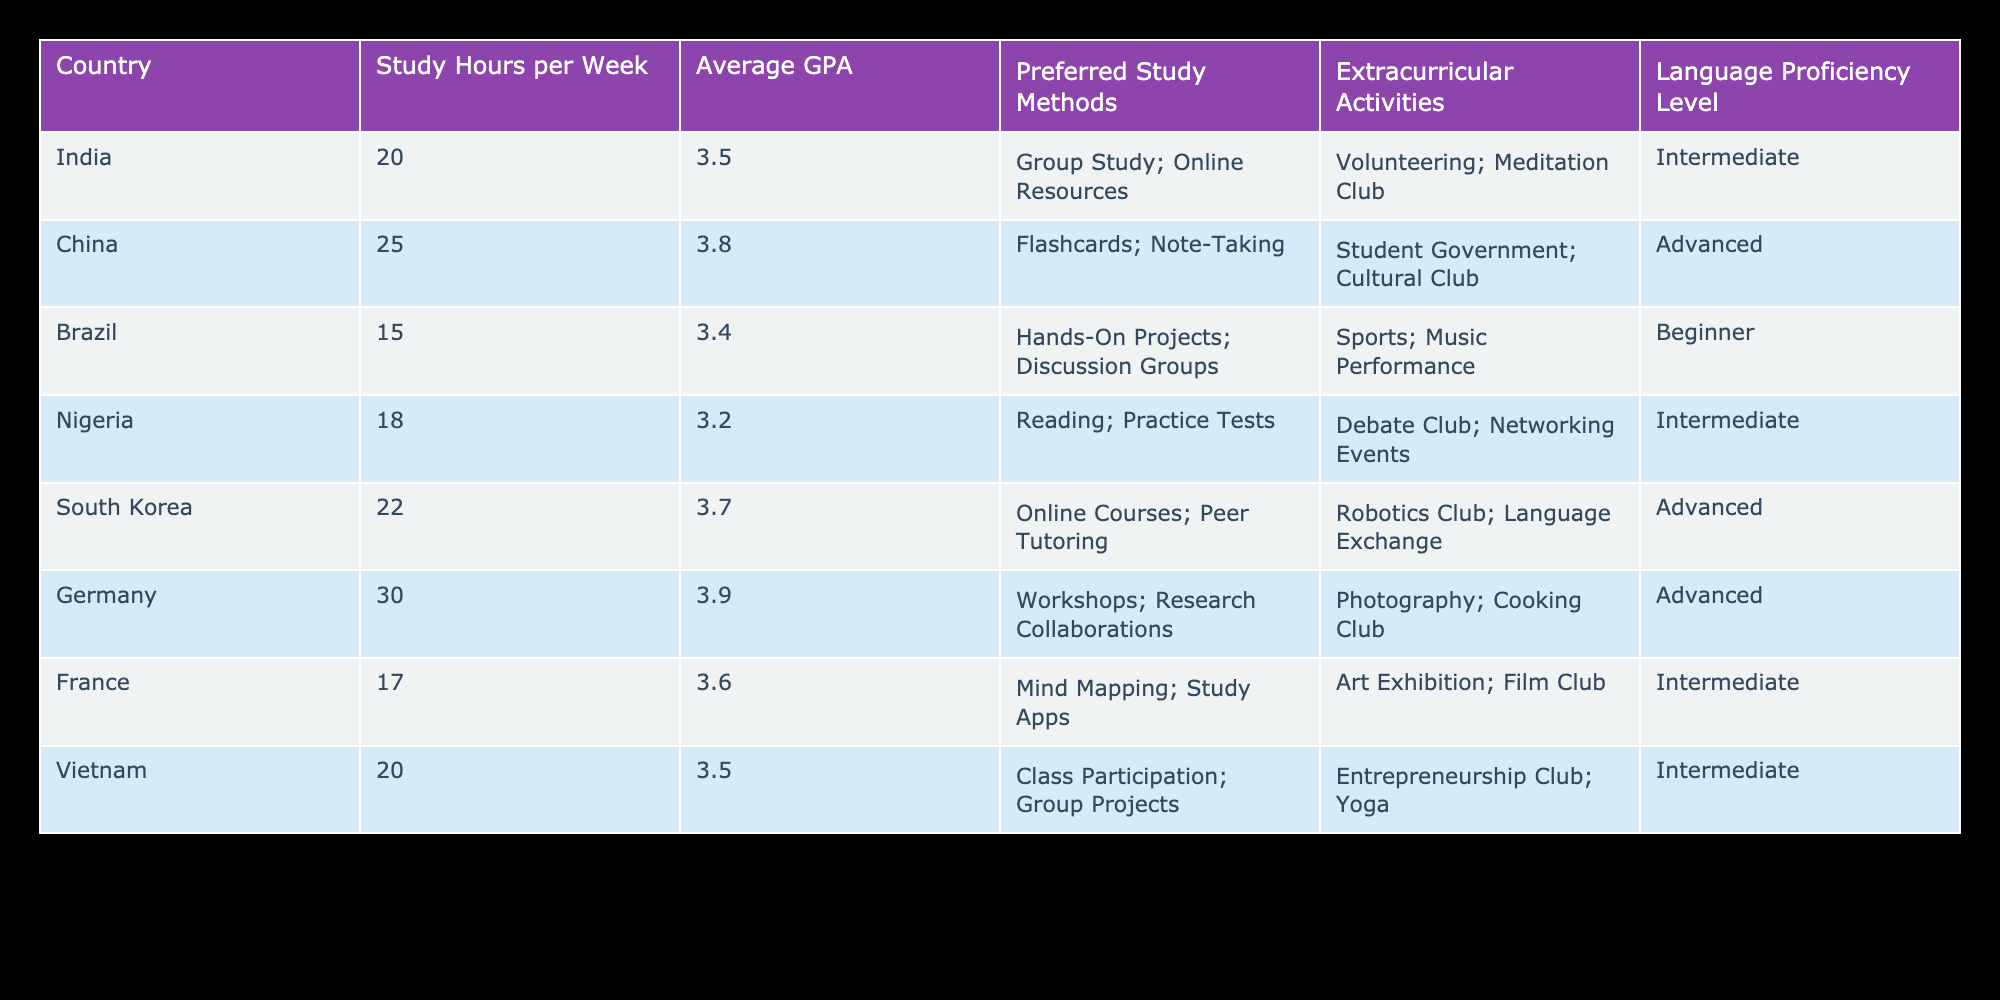What is the average GPA of the students from India? From the table, the GPA for students from India is 3.5. As there is only one entry for India, the average GPA is the same as the individual GPA value.
Answer: 3.5 Which country has the highest average GPA? By comparing the GPA values in the table, Germany has the GPA of 3.9, which is the highest among all the countries listed.
Answer: Germany What study method is preferred by students from Brazil? According to the table, students from Brazil prefer "Hands-On Projects" and "Discussion Groups" as their study methods.
Answer: Hands-On Projects; Discussion Groups Is it true that students from Nigeria have better language proficiency levels than those from Brazil? The table indicates that Nigeria has an "Intermediate" language proficiency level while Brazil has a "Beginner" level. Therefore, it is true that students from Nigeria have better language proficiency levels than those from Brazil.
Answer: Yes What is the difference in study hours per week between students from China and those from France? The study hours for China are 25, and for France, it’s 17. To find the difference, subtract the hours for France from those for China: 25 - 17 = 8.
Answer: 8 What is the average number of study hours per week for students from countries with an advanced language proficiency level? The countries with an advanced level are China, South Korea, and Germany, with study hours of 25, 22, and 30 respectively. To find the average, sum these hours: 25 + 22 + 30 = 77, then divide by the number of countries (3): 77 / 3 ≈ 25.67.
Answer: 25.67 How many countries have students who participate in extracurricular activities related to clubs or groups? In the table, the countries with students involved in clubs or groups are China, South Korea, Nigeria, and France. Counting these, there are a total of 4 countries.
Answer: 4 Which study method is the most common among the countries, and how many students prefer it? The study methods listed are all different; for example, "Group Study" appears for India, while "Flashcards" is for China. Hence, there isn’t a single common method among all countries.
Answer: No common method Do students from Vietnam participate in extracurricular activities? The table shows that students from Vietnam are active in the "Entrepreneurship Club" and "Yoga", indicating they do participate in extracurricular activities.
Answer: Yes 